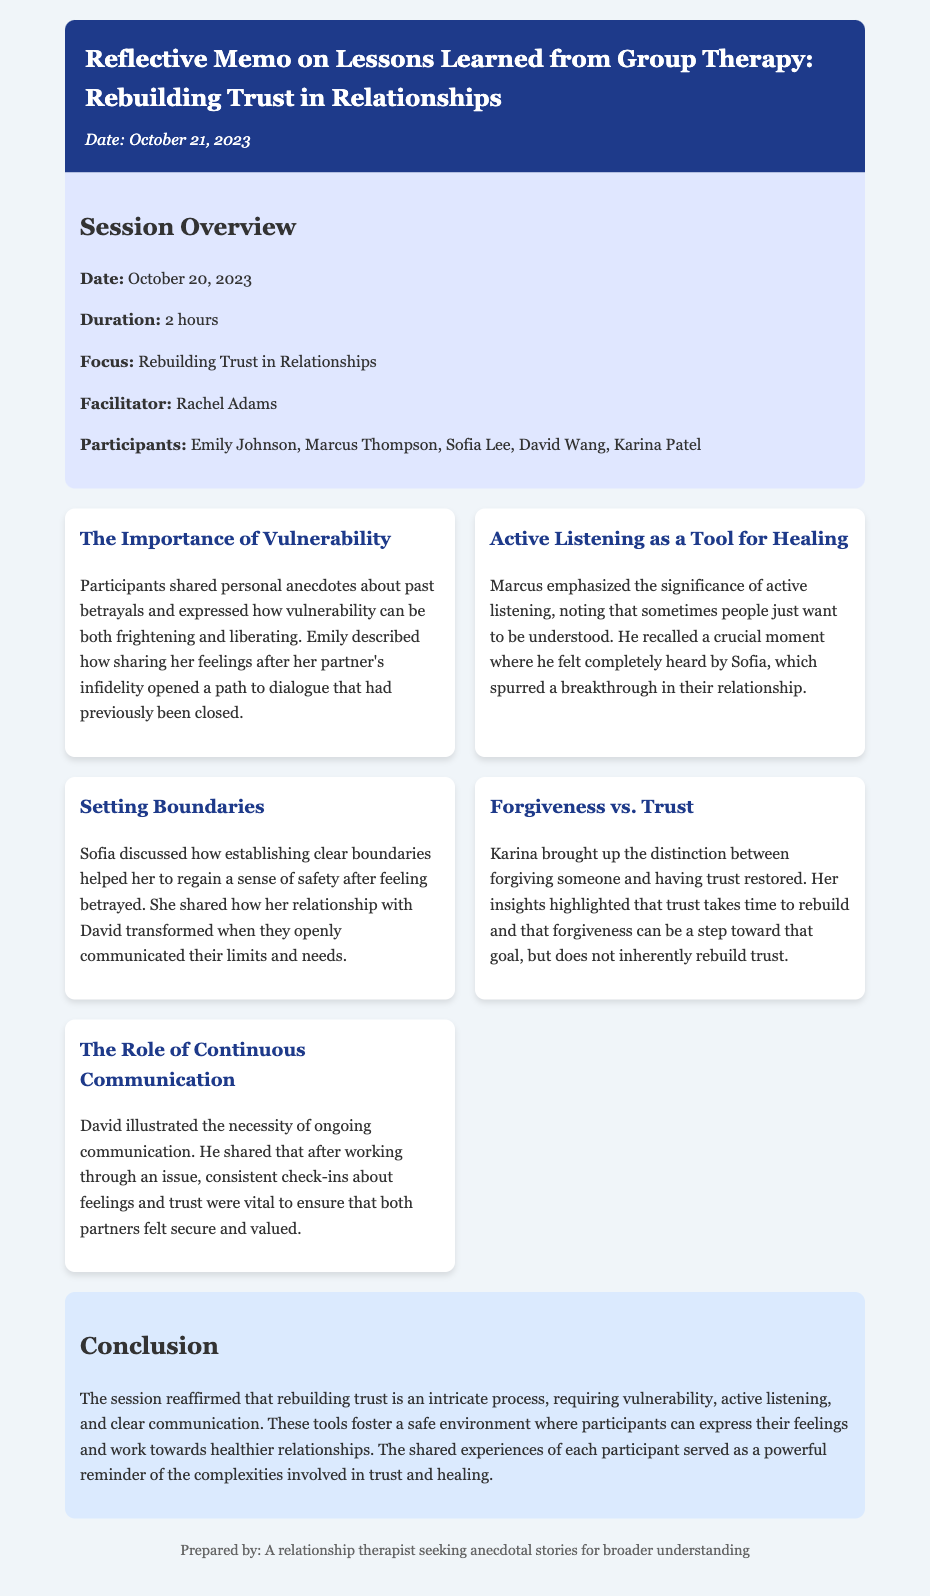What is the date of the therapy session? The document states that the therapy session took place on October 20, 2023.
Answer: October 20, 2023 Who facilitated the session? The facilitator of the session is mentioned in the document as Rachel Adams.
Answer: Rachel Adams How long was the therapy session? The duration of the session is noted as 2 hours.
Answer: 2 hours Which participant shared a story about vulnerability? Emily is the participant who shared personal anecdotes about past betrayals related to vulnerability.
Answer: Emily What key lesson did Marcus emphasize? Marcus emphasized the importance of active listening as a way to promote healing in relationships.
Answer: Active listening What is the distinction Karina made in the session? Karina highlighted the difference between forgiving someone and having trust restored.
Answer: Forgiveness vs. Trust What role did David emphasize in rebuilding trust? David stressed the necessity of ongoing communication for rebuilding trust.
Answer: Continuous Communication What does the conclusion say about the nature of rebuilding trust? The conclusion states that rebuilding trust is an intricate process.
Answer: Intricate process 